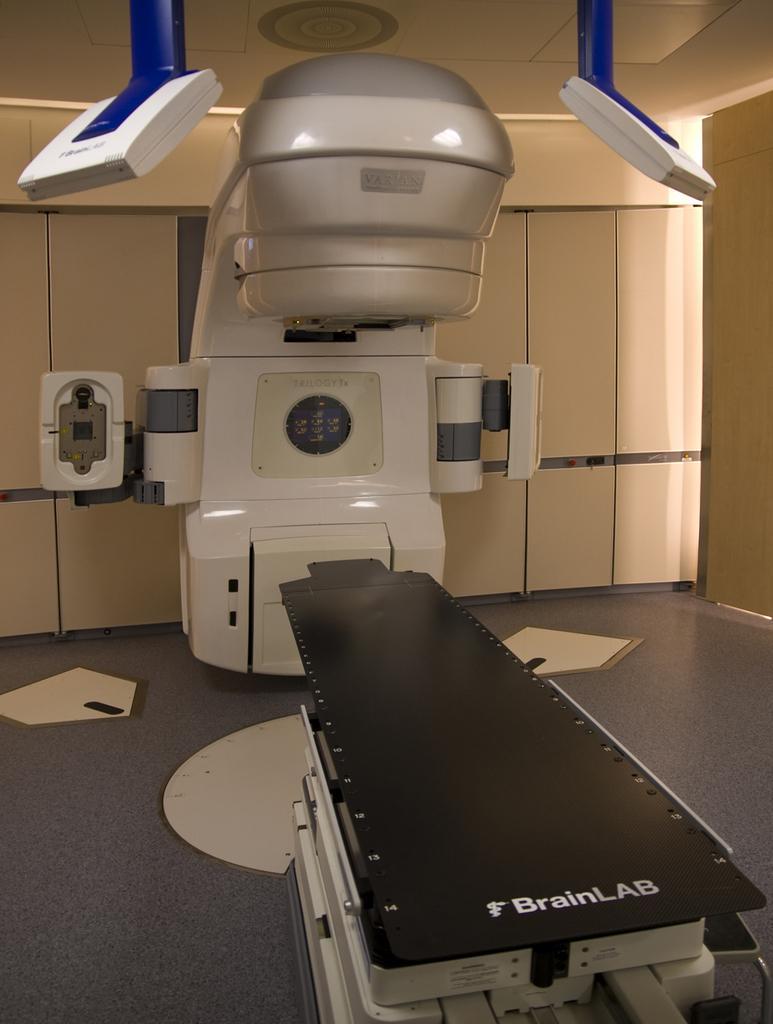How would you summarize this image in a sentence or two? We can see machines and floor. We can see wall. 